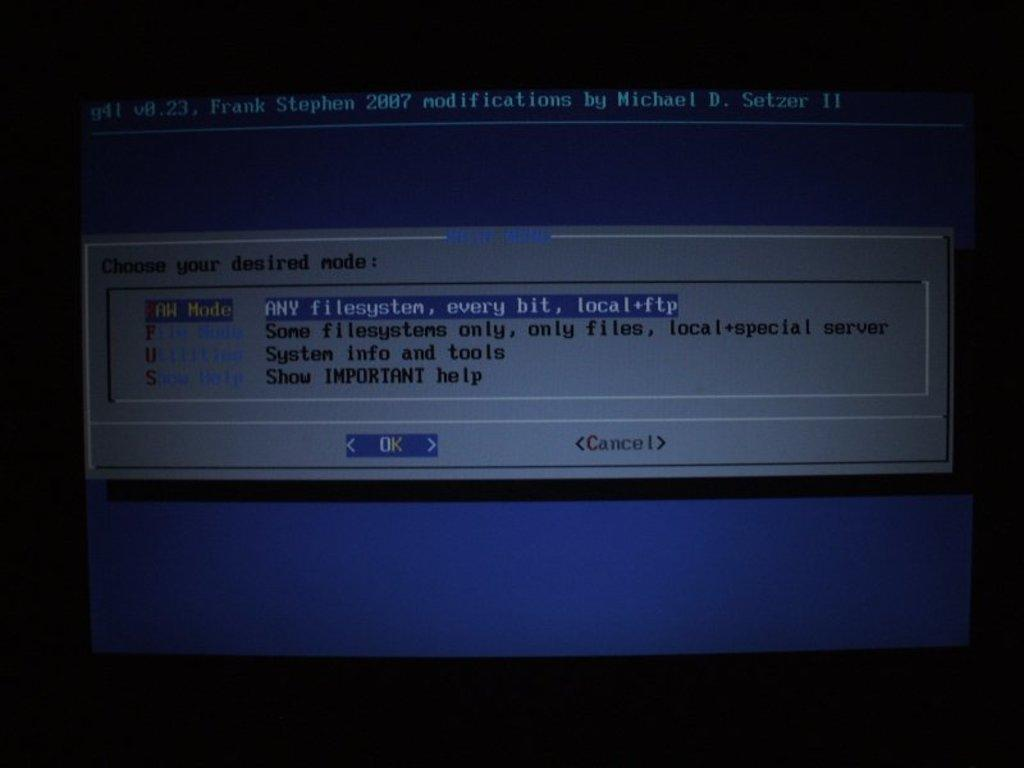<image>
Present a compact description of the photo's key features. A notification on the computer screen has the OK button highlighted. 